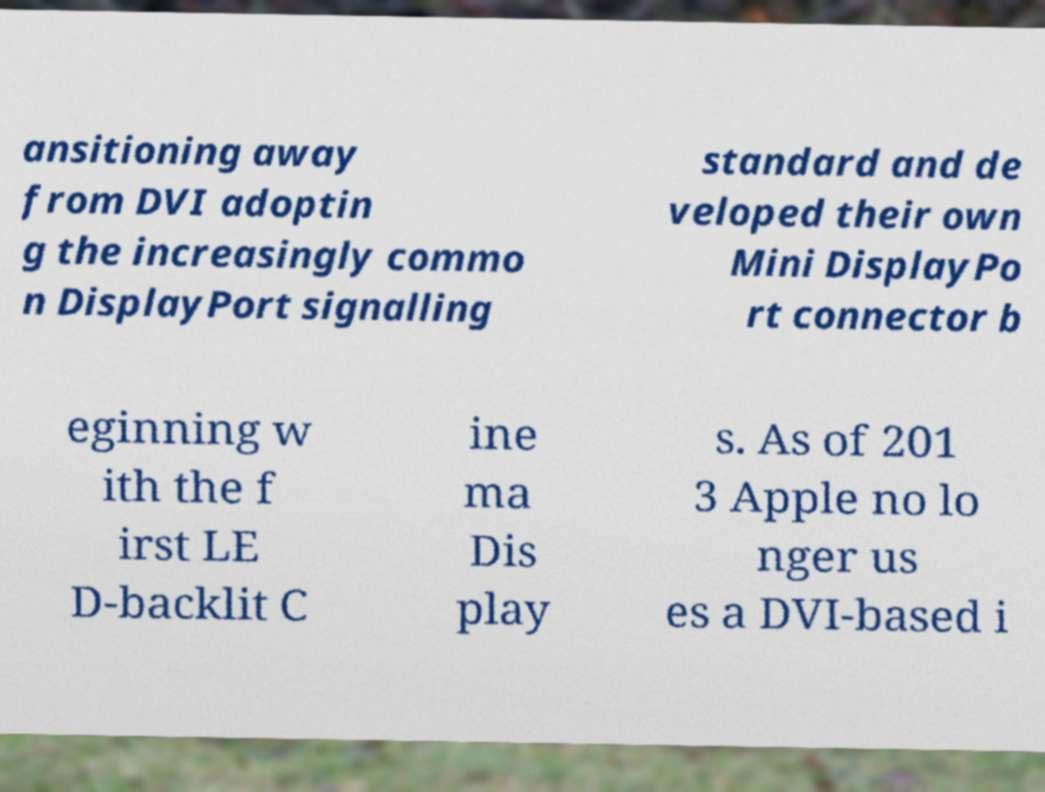I need the written content from this picture converted into text. Can you do that? ansitioning away from DVI adoptin g the increasingly commo n DisplayPort signalling standard and de veloped their own Mini DisplayPo rt connector b eginning w ith the f irst LE D-backlit C ine ma Dis play s. As of 201 3 Apple no lo nger us es a DVI-based i 